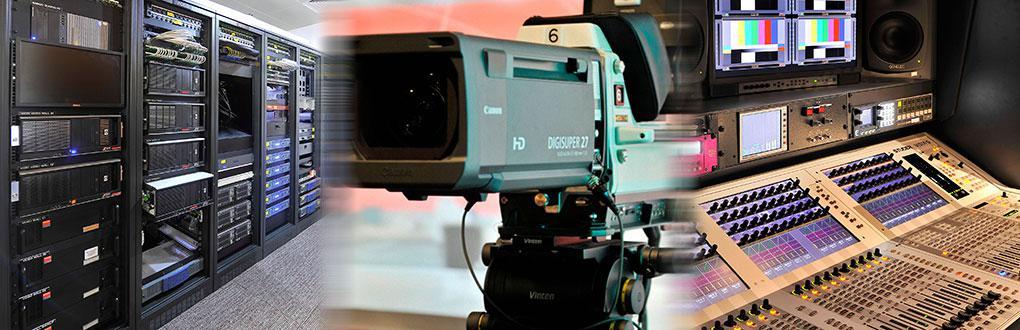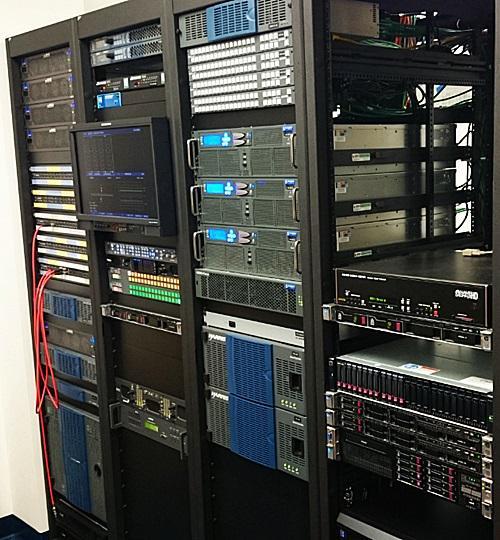The first image is the image on the left, the second image is the image on the right. For the images displayed, is the sentence "There is at least one person in the image on the left." factually correct? Answer yes or no. No. 